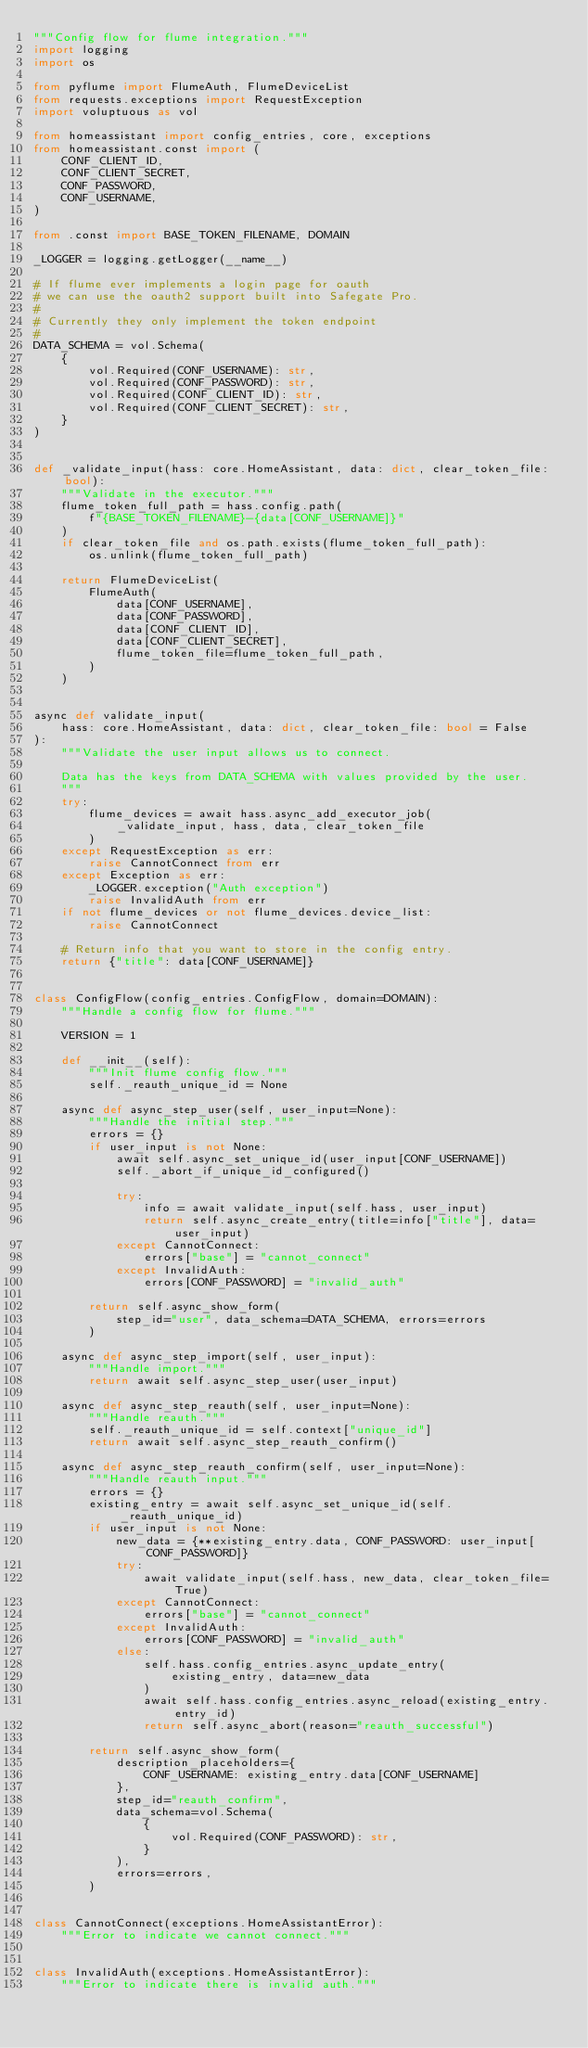<code> <loc_0><loc_0><loc_500><loc_500><_Python_>"""Config flow for flume integration."""
import logging
import os

from pyflume import FlumeAuth, FlumeDeviceList
from requests.exceptions import RequestException
import voluptuous as vol

from homeassistant import config_entries, core, exceptions
from homeassistant.const import (
    CONF_CLIENT_ID,
    CONF_CLIENT_SECRET,
    CONF_PASSWORD,
    CONF_USERNAME,
)

from .const import BASE_TOKEN_FILENAME, DOMAIN

_LOGGER = logging.getLogger(__name__)

# If flume ever implements a login page for oauth
# we can use the oauth2 support built into Safegate Pro.
#
# Currently they only implement the token endpoint
#
DATA_SCHEMA = vol.Schema(
    {
        vol.Required(CONF_USERNAME): str,
        vol.Required(CONF_PASSWORD): str,
        vol.Required(CONF_CLIENT_ID): str,
        vol.Required(CONF_CLIENT_SECRET): str,
    }
)


def _validate_input(hass: core.HomeAssistant, data: dict, clear_token_file: bool):
    """Validate in the executor."""
    flume_token_full_path = hass.config.path(
        f"{BASE_TOKEN_FILENAME}-{data[CONF_USERNAME]}"
    )
    if clear_token_file and os.path.exists(flume_token_full_path):
        os.unlink(flume_token_full_path)

    return FlumeDeviceList(
        FlumeAuth(
            data[CONF_USERNAME],
            data[CONF_PASSWORD],
            data[CONF_CLIENT_ID],
            data[CONF_CLIENT_SECRET],
            flume_token_file=flume_token_full_path,
        )
    )


async def validate_input(
    hass: core.HomeAssistant, data: dict, clear_token_file: bool = False
):
    """Validate the user input allows us to connect.

    Data has the keys from DATA_SCHEMA with values provided by the user.
    """
    try:
        flume_devices = await hass.async_add_executor_job(
            _validate_input, hass, data, clear_token_file
        )
    except RequestException as err:
        raise CannotConnect from err
    except Exception as err:
        _LOGGER.exception("Auth exception")
        raise InvalidAuth from err
    if not flume_devices or not flume_devices.device_list:
        raise CannotConnect

    # Return info that you want to store in the config entry.
    return {"title": data[CONF_USERNAME]}


class ConfigFlow(config_entries.ConfigFlow, domain=DOMAIN):
    """Handle a config flow for flume."""

    VERSION = 1

    def __init__(self):
        """Init flume config flow."""
        self._reauth_unique_id = None

    async def async_step_user(self, user_input=None):
        """Handle the initial step."""
        errors = {}
        if user_input is not None:
            await self.async_set_unique_id(user_input[CONF_USERNAME])
            self._abort_if_unique_id_configured()

            try:
                info = await validate_input(self.hass, user_input)
                return self.async_create_entry(title=info["title"], data=user_input)
            except CannotConnect:
                errors["base"] = "cannot_connect"
            except InvalidAuth:
                errors[CONF_PASSWORD] = "invalid_auth"

        return self.async_show_form(
            step_id="user", data_schema=DATA_SCHEMA, errors=errors
        )

    async def async_step_import(self, user_input):
        """Handle import."""
        return await self.async_step_user(user_input)

    async def async_step_reauth(self, user_input=None):
        """Handle reauth."""
        self._reauth_unique_id = self.context["unique_id"]
        return await self.async_step_reauth_confirm()

    async def async_step_reauth_confirm(self, user_input=None):
        """Handle reauth input."""
        errors = {}
        existing_entry = await self.async_set_unique_id(self._reauth_unique_id)
        if user_input is not None:
            new_data = {**existing_entry.data, CONF_PASSWORD: user_input[CONF_PASSWORD]}
            try:
                await validate_input(self.hass, new_data, clear_token_file=True)
            except CannotConnect:
                errors["base"] = "cannot_connect"
            except InvalidAuth:
                errors[CONF_PASSWORD] = "invalid_auth"
            else:
                self.hass.config_entries.async_update_entry(
                    existing_entry, data=new_data
                )
                await self.hass.config_entries.async_reload(existing_entry.entry_id)
                return self.async_abort(reason="reauth_successful")

        return self.async_show_form(
            description_placeholders={
                CONF_USERNAME: existing_entry.data[CONF_USERNAME]
            },
            step_id="reauth_confirm",
            data_schema=vol.Schema(
                {
                    vol.Required(CONF_PASSWORD): str,
                }
            ),
            errors=errors,
        )


class CannotConnect(exceptions.HomeAssistantError):
    """Error to indicate we cannot connect."""


class InvalidAuth(exceptions.HomeAssistantError):
    """Error to indicate there is invalid auth."""
</code> 